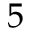<formula> <loc_0><loc_0><loc_500><loc_500>5</formula> 